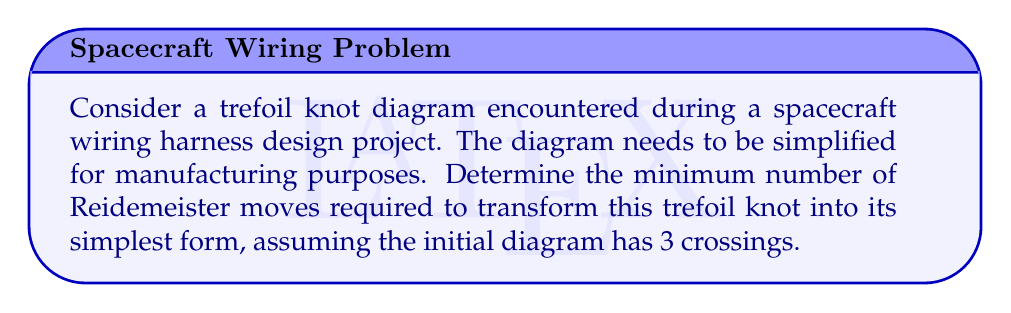Provide a solution to this math problem. Let's approach this step-by-step:

1) The trefoil knot is the simplest non-trivial knot. Its standard diagram has 3 crossings, which is already the simplest form for this knot type.

2) Reidemeister moves are local changes to a knot diagram that do not change the knot type. There are three types of Reidemeister moves:
   - Type I: Twisting or untwisting a strand
   - Type II: Moving one strand completely over or under another
   - Type III: Moving a strand over or under a crossing

3) For the trefoil knot:
   - We cannot reduce the number of crossings below 3 without changing the knot type.
   - Any sequence of Reidemeister moves that returns to the same 3-crossing diagram is considered unnecessary for simplification.

4) Since the trefoil knot with 3 crossings is already in its simplest form, no Reidemeister moves are required to simplify it further.

5) However, it's worth noting that Reidemeister moves can be used to change the appearance of the trefoil knot while maintaining its 3 crossings. For example:
   - A sequence of three Type III moves can rotate the crossings of a trefoil knot.
   - This might be useful for orienting the knot diagram in a specific way for the wiring harness design, but it doesn't simplify the knot further.

Therefore, the minimum number of Reidemeister moves required to transform the trefoil knot into its simplest form is 0, as it is already in its simplest form with 3 crossings.
Answer: 0 moves 